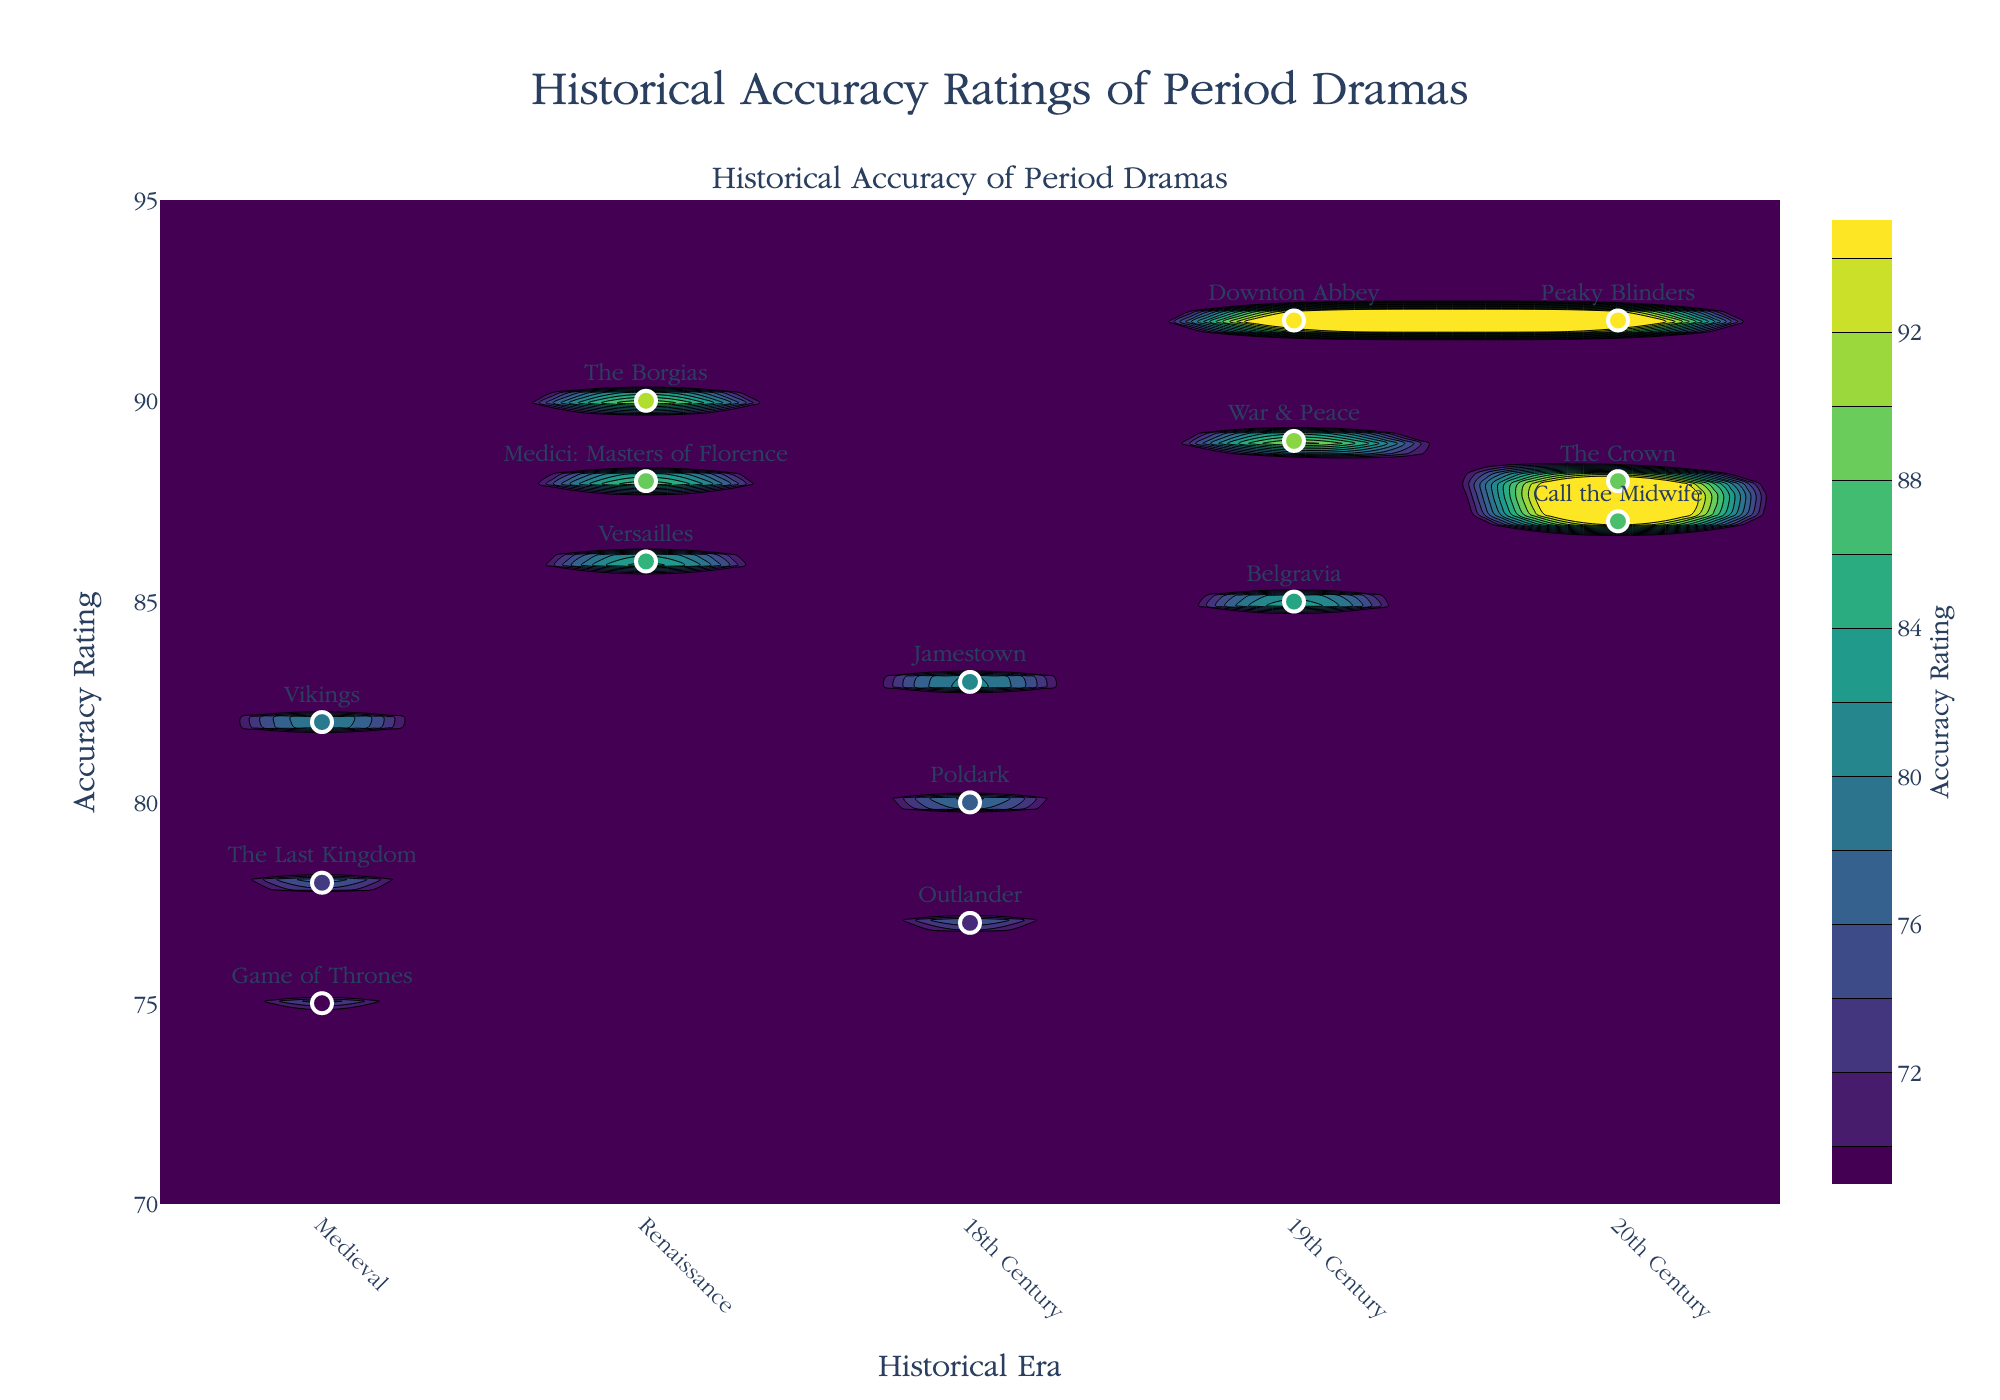What is the title of the figure? The title is usually found at the top of the figure, centered and in a slightly larger font size than other text. The title in this figure is "Historical Accuracy Ratings of Period Dramas".
Answer: Historical Accuracy Ratings of Period Dramas What are the historical eras depicted on the x-axis? The x-axis labels the historical eras, which can be found at the bottom of the figure. The eras displayed are Medieval, Renaissance, 18th Century, 19th Century, and 20th Century.
Answer: Medieval, Renaissance, 18th Century, 19th Century, 20th Century Which series has the highest historical accuracy rating? By looking at the y-axis, which represents the accuracy rating, we find the highest data point. The scatter plot text labels indicate that the series with the highest rating is "Downton Abbey" in the 19th Century with a rating of 92.
Answer: Downton Abbey How does the accuracy rating change across different historical eras? To answer this, visually inspect the contour plot and scatter points. The general trend shows that accuracy ratings tend to be higher in later eras (19th and 20th Century), with peaks around 90-92 and slight dips in the 18th Century.
Answer: Higher in 19th and 20th Century What is the highest accuracy rating for series set in the Medieval era? Look at the scatter points labeled as Medieval on the x-axis, then find the one with the highest y-value. The highest rating is for the series "Vikings" with a rating of 82.
Answer: 82 Which series in the 20th Century era has the lowest accuracy rating? By locating the scatter points for the 20th Century on the x-axis, identify the one with the lowest y-value. The series with the lowest rating is "Call the Midwife" with a rating of 87.
Answer: Call the Midwife Compare the historical accuracy ratings between Renaissance and 18th Century period dramas. Which era has higher ratings on average? Identify and list the ratings for Renaissance (90, 88, 86) and 18th Century (80, 77, 83). Calculate the average for both: Renaissance (90+88+86)/3 = 88, 18th Century (80+77+83)/3 ≈ 80.
Answer: Renaissance What does the color scale represent in the contour plot? The legend or color bar usually explains what the colors depict in the plot. In this figure, the color scale represents the range of accuracy ratings, spanning from lower ratings (lighter colors) to higher ratings (darker colors).
Answer: Accuracy Rating How many series have an accuracy rating greater than or equal to 90? Check the scatter points and note the series names with ratings 90 or above: "Downton Abbey" (92), "The Crown" (92), "Peaky Blinders" (92), "The Borgias" (90). Count them up to get the total.
Answer: Four What is the range of accuracy ratings for series set in the 18th Century? Identify the scatter points for the 18th Century on the x-axis and find the highest and lowest y-values, which are 83 and 77, respectively. The range is the difference between these two values: 83 - 77 = 6.
Answer: 6 